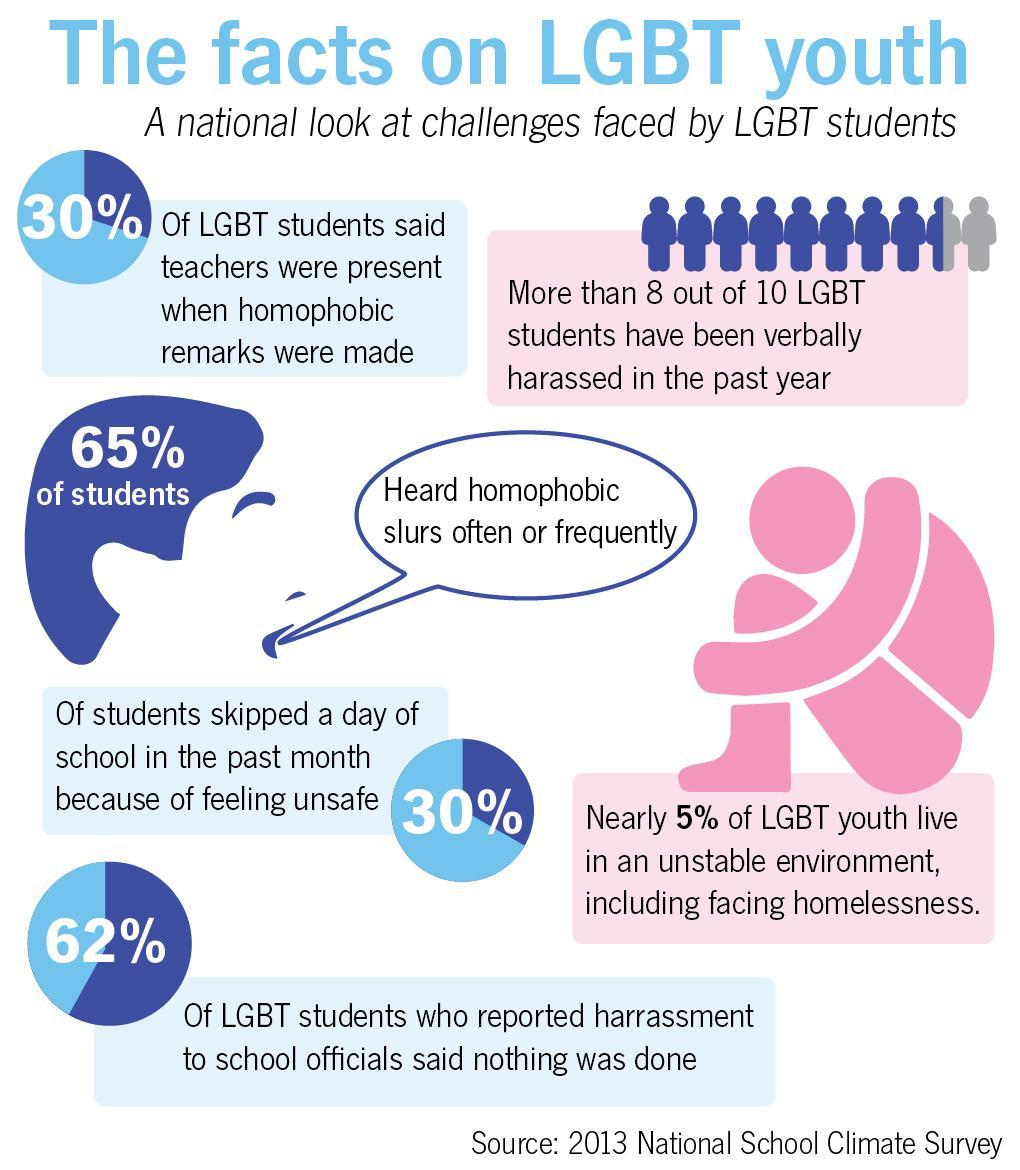Point out several critical features in this image. The report found that in 62% of the cases studied, inaction by school authorities was a factor in the sexual misconduct that occurred. It is estimated that approximately 30% of the students skipped school. 